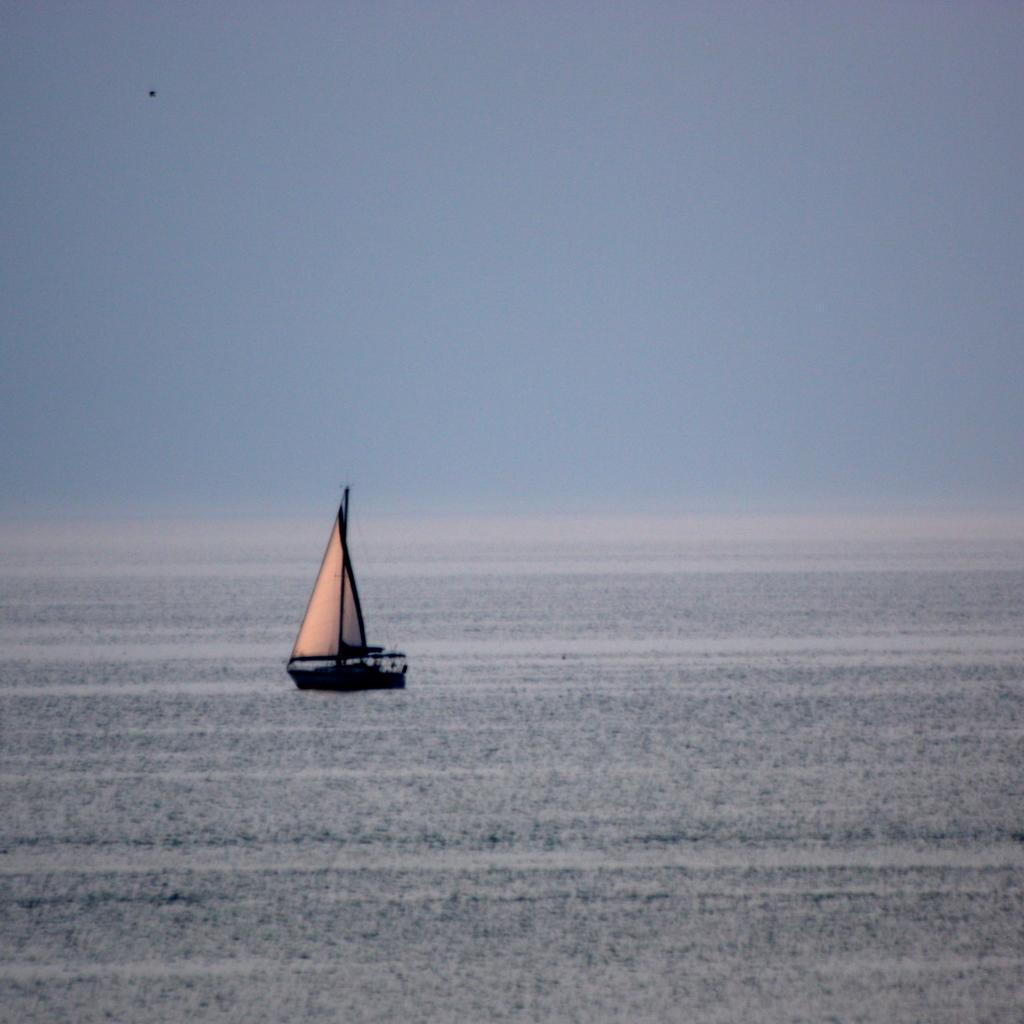Please provide a concise description of this image. In this image in the middle there is a ship and in the background is the sky and it looks like blue in color. 